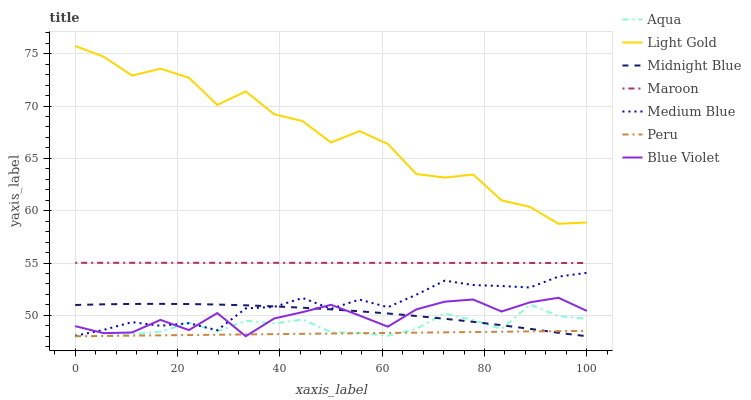Does Peru have the minimum area under the curve?
Answer yes or no. Yes. Does Light Gold have the maximum area under the curve?
Answer yes or no. Yes. Does Aqua have the minimum area under the curve?
Answer yes or no. No. Does Aqua have the maximum area under the curve?
Answer yes or no. No. Is Peru the smoothest?
Answer yes or no. Yes. Is Light Gold the roughest?
Answer yes or no. Yes. Is Aqua the smoothest?
Answer yes or no. No. Is Aqua the roughest?
Answer yes or no. No. Does Medium Blue have the lowest value?
Answer yes or no. No. Does Light Gold have the highest value?
Answer yes or no. Yes. Does Aqua have the highest value?
Answer yes or no. No. Is Peru less than Medium Blue?
Answer yes or no. Yes. Is Light Gold greater than Aqua?
Answer yes or no. Yes. Does Blue Violet intersect Aqua?
Answer yes or no. Yes. Is Blue Violet less than Aqua?
Answer yes or no. No. Is Blue Violet greater than Aqua?
Answer yes or no. No. Does Peru intersect Medium Blue?
Answer yes or no. No. 